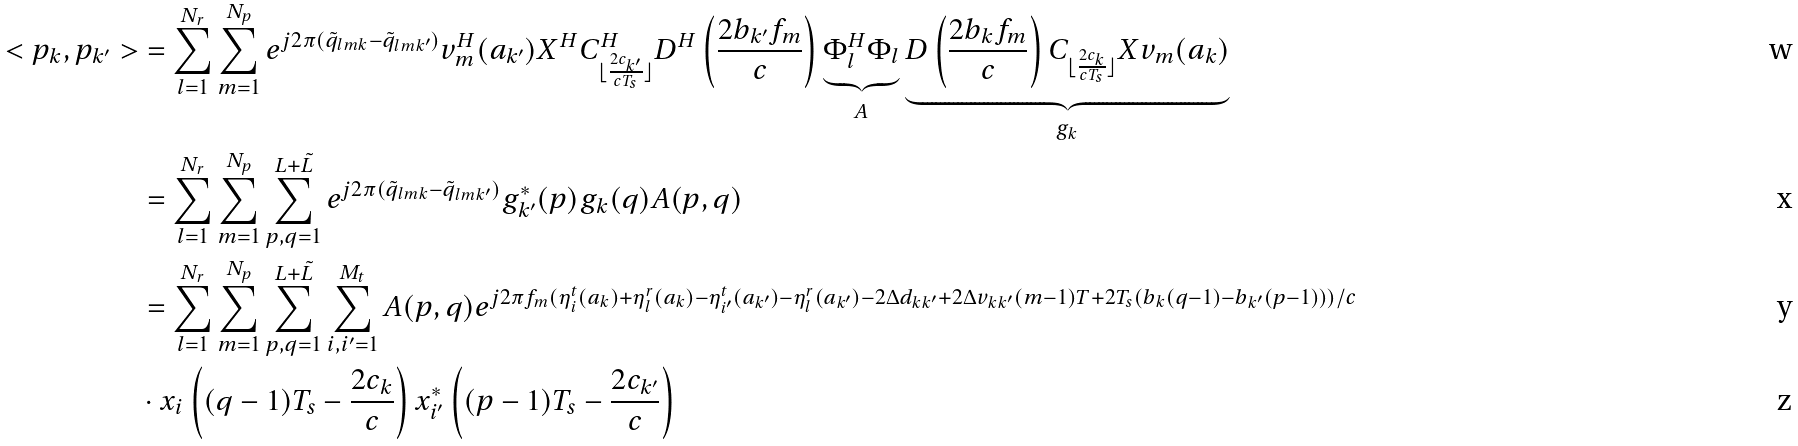Convert formula to latex. <formula><loc_0><loc_0><loc_500><loc_500>< { p } _ { k } , { p } _ { k ^ { \prime } } > & = \sum _ { l = 1 } ^ { N _ { r } } \sum _ { m = 1 } ^ { N _ { p } } e ^ { j 2 \pi ( \tilde { q } _ { l m k } - \tilde { q } _ { l m k ^ { \prime } } ) } { v } _ { m } ^ { H } ( a _ { k ^ { \prime } } ) { X } ^ { H } { C } _ { \lfloor \frac { 2 c _ { k ^ { \prime } } } { c T _ { s } } \rfloor } ^ { H } { D } ^ { H } \left ( \frac { 2 b _ { k ^ { \prime } } f _ { m } } { c } \right ) \underbrace { { \Phi } _ { l } ^ { H } { \Phi } _ { l } } _ { A } \underbrace { { D } \left ( \frac { 2 b _ { k } f _ { m } } { c } \right ) { C } _ { \lfloor \frac { 2 c _ { k } } { c T _ { s } } \rfloor } { X } { v } _ { m } ( a _ { k } ) } _ { g _ { k } } \\ & = \sum _ { l = 1 } ^ { N _ { r } } \sum _ { m = 1 } ^ { N _ { p } } \sum _ { p , q = 1 } ^ { L + \tilde { L } } e ^ { j 2 \pi ( \tilde { q } _ { l m k } - \tilde { q } _ { l m k ^ { \prime } } ) } { g } ^ { * } _ { k ^ { \prime } } ( p ) { g } _ { k } ( q ) { A } ( p , q ) \\ & = \sum _ { l = 1 } ^ { N _ { r } } \sum _ { m = 1 } ^ { N _ { p } } \sum _ { p , q = 1 } ^ { L + \tilde { L } } \sum _ { i , i ^ { \prime } = 1 } ^ { M _ { t } } { A } ( p , q ) e ^ { j 2 \pi f _ { m } ( \eta _ { i } ^ { t } ( a _ { k } ) + \eta _ { l } ^ { r } ( a _ { k } ) - \eta _ { i ^ { \prime } } ^ { t } ( a _ { k ^ { \prime } } ) - \eta _ { l } ^ { r } ( a _ { k ^ { \prime } } ) - 2 \Delta d _ { k k ^ { \prime } } + 2 \Delta v _ { k k ^ { \prime } } ( m - 1 ) T + 2 T _ { s } ( b _ { k } ( q - 1 ) - b _ { k ^ { \prime } } ( p - 1 ) ) ) / c } \\ & \cdot x _ { i } \left ( ( q - 1 ) T _ { s } - \frac { 2 c _ { k } } { c } \right ) x ^ { * } _ { i ^ { \prime } } \left ( ( p - 1 ) T _ { s } - \frac { 2 c _ { k ^ { \prime } } } { c } \right )</formula> 